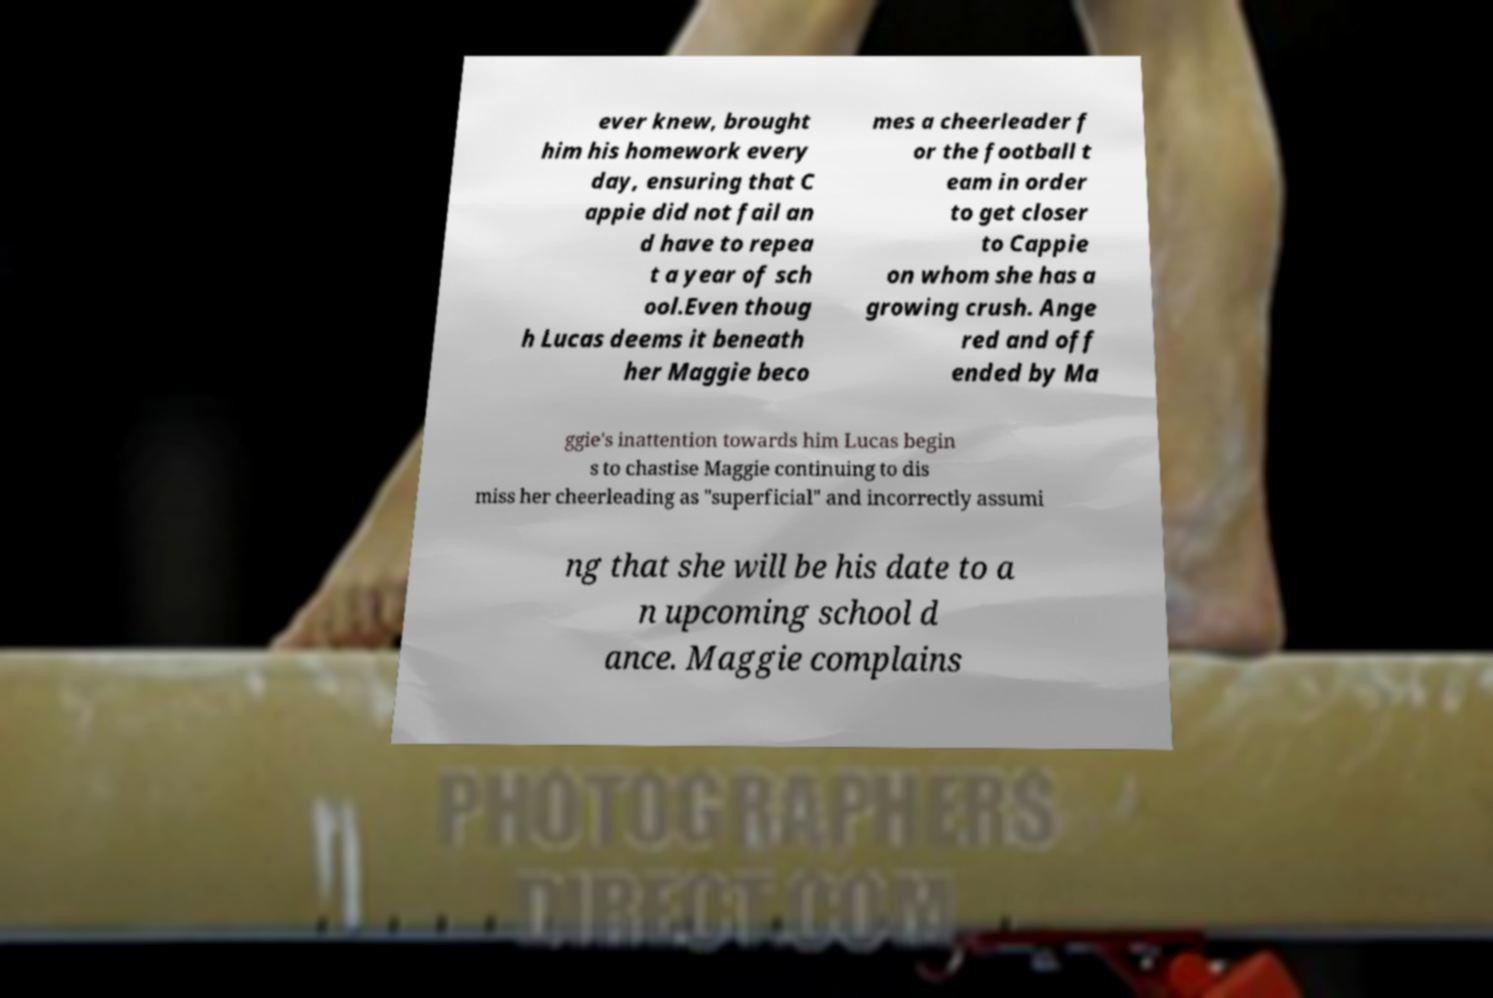Please identify and transcribe the text found in this image. ever knew, brought him his homework every day, ensuring that C appie did not fail an d have to repea t a year of sch ool.Even thoug h Lucas deems it beneath her Maggie beco mes a cheerleader f or the football t eam in order to get closer to Cappie on whom she has a growing crush. Ange red and off ended by Ma ggie's inattention towards him Lucas begin s to chastise Maggie continuing to dis miss her cheerleading as "superficial" and incorrectly assumi ng that she will be his date to a n upcoming school d ance. Maggie complains 